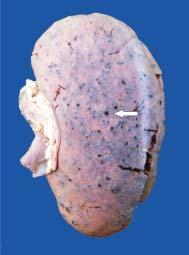how is the kidney?
Answer the question using a single word or phrase. Enlarged in size and weight 